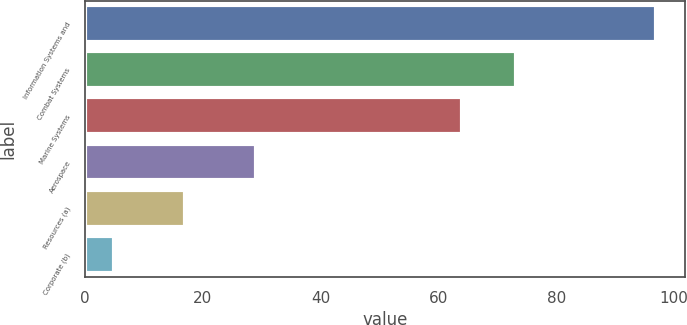<chart> <loc_0><loc_0><loc_500><loc_500><bar_chart><fcel>Information Systems and<fcel>Combat Systems<fcel>Marine Systems<fcel>Aerospace<fcel>Resources (a)<fcel>Corporate (b)<nl><fcel>97<fcel>73.2<fcel>64<fcel>29<fcel>17<fcel>5<nl></chart> 